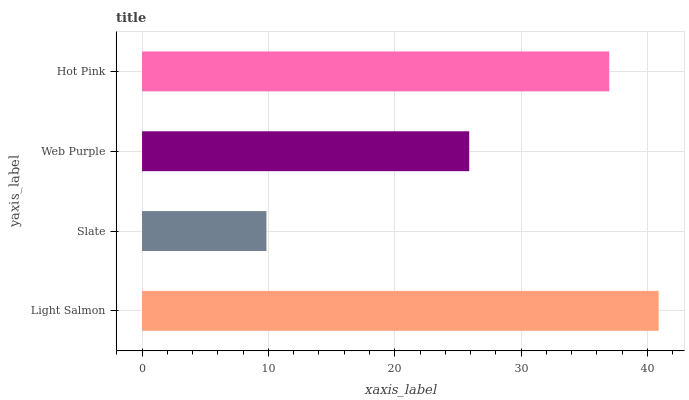Is Slate the minimum?
Answer yes or no. Yes. Is Light Salmon the maximum?
Answer yes or no. Yes. Is Web Purple the minimum?
Answer yes or no. No. Is Web Purple the maximum?
Answer yes or no. No. Is Web Purple greater than Slate?
Answer yes or no. Yes. Is Slate less than Web Purple?
Answer yes or no. Yes. Is Slate greater than Web Purple?
Answer yes or no. No. Is Web Purple less than Slate?
Answer yes or no. No. Is Hot Pink the high median?
Answer yes or no. Yes. Is Web Purple the low median?
Answer yes or no. Yes. Is Slate the high median?
Answer yes or no. No. Is Slate the low median?
Answer yes or no. No. 